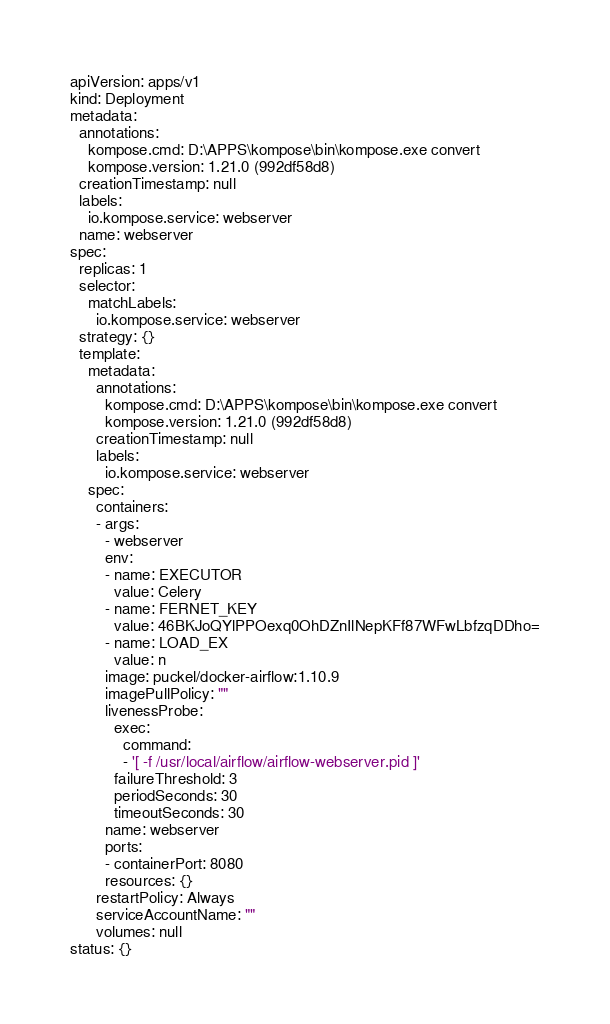Convert code to text. <code><loc_0><loc_0><loc_500><loc_500><_YAML_>apiVersion: apps/v1
kind: Deployment
metadata:
  annotations:
    kompose.cmd: D:\APPS\kompose\bin\kompose.exe convert
    kompose.version: 1.21.0 (992df58d8)
  creationTimestamp: null
  labels:
    io.kompose.service: webserver
  name: webserver
spec:
  replicas: 1
  selector:
    matchLabels:
      io.kompose.service: webserver
  strategy: {}
  template:
    metadata:
      annotations:
        kompose.cmd: D:\APPS\kompose\bin\kompose.exe convert
        kompose.version: 1.21.0 (992df58d8)
      creationTimestamp: null
      labels:
        io.kompose.service: webserver
    spec:
      containers:
      - args:
        - webserver
        env:
        - name: EXECUTOR
          value: Celery
        - name: FERNET_KEY
          value: 46BKJoQYlPPOexq0OhDZnIlNepKFf87WFwLbfzqDDho=
        - name: LOAD_EX
          value: n
        image: puckel/docker-airflow:1.10.9
        imagePullPolicy: ""
        livenessProbe:
          exec:
            command:
            - '[ -f /usr/local/airflow/airflow-webserver.pid ]'
          failureThreshold: 3
          periodSeconds: 30
          timeoutSeconds: 30
        name: webserver
        ports:
        - containerPort: 8080
        resources: {}
      restartPolicy: Always
      serviceAccountName: ""
      volumes: null
status: {}
</code> 